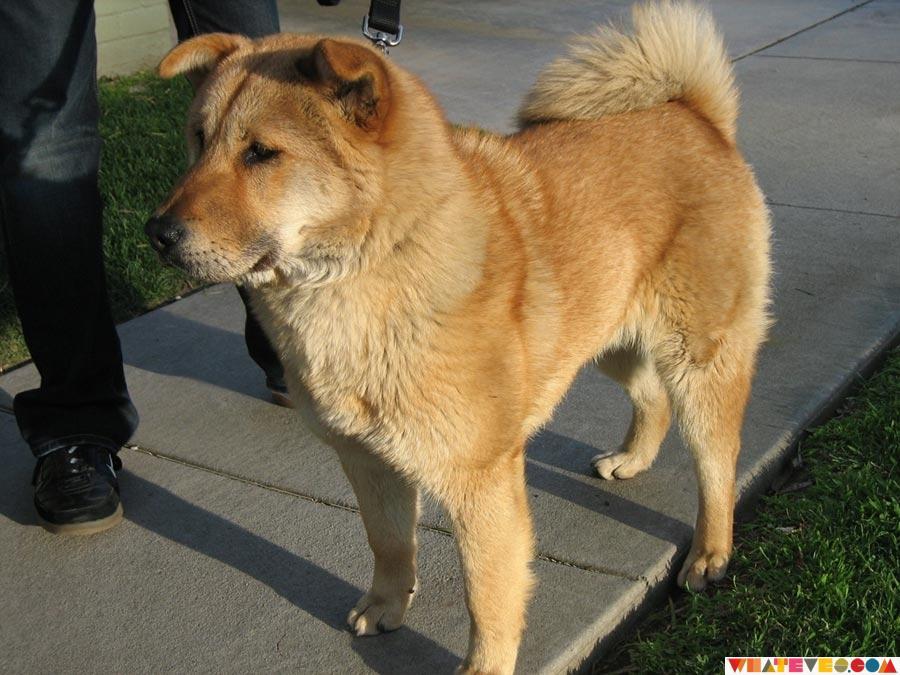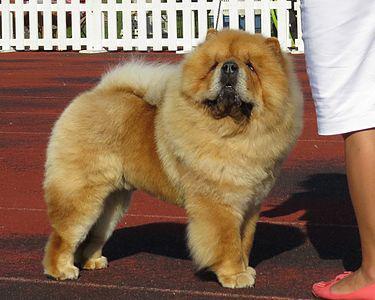The first image is the image on the left, the second image is the image on the right. For the images shown, is this caption "A man in a light blue shirt is holding two puppies." true? Answer yes or no. No. 